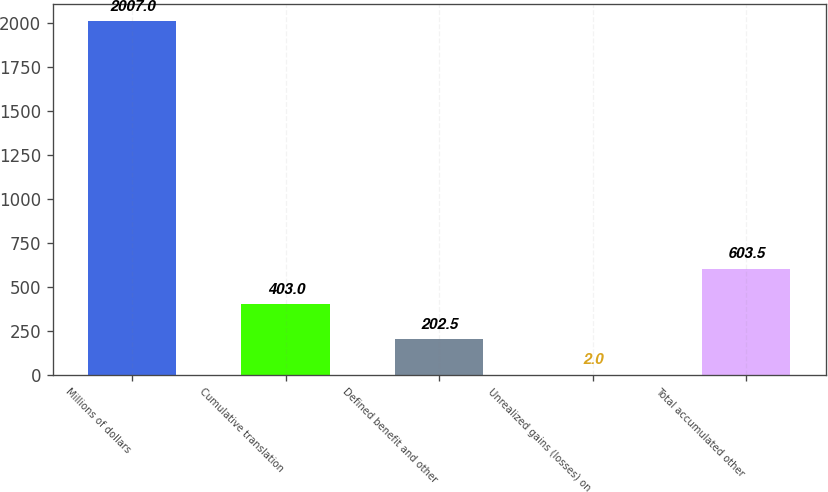Convert chart to OTSL. <chart><loc_0><loc_0><loc_500><loc_500><bar_chart><fcel>Millions of dollars<fcel>Cumulative translation<fcel>Defined benefit and other<fcel>Unrealized gains (losses) on<fcel>Total accumulated other<nl><fcel>2007<fcel>403<fcel>202.5<fcel>2<fcel>603.5<nl></chart> 